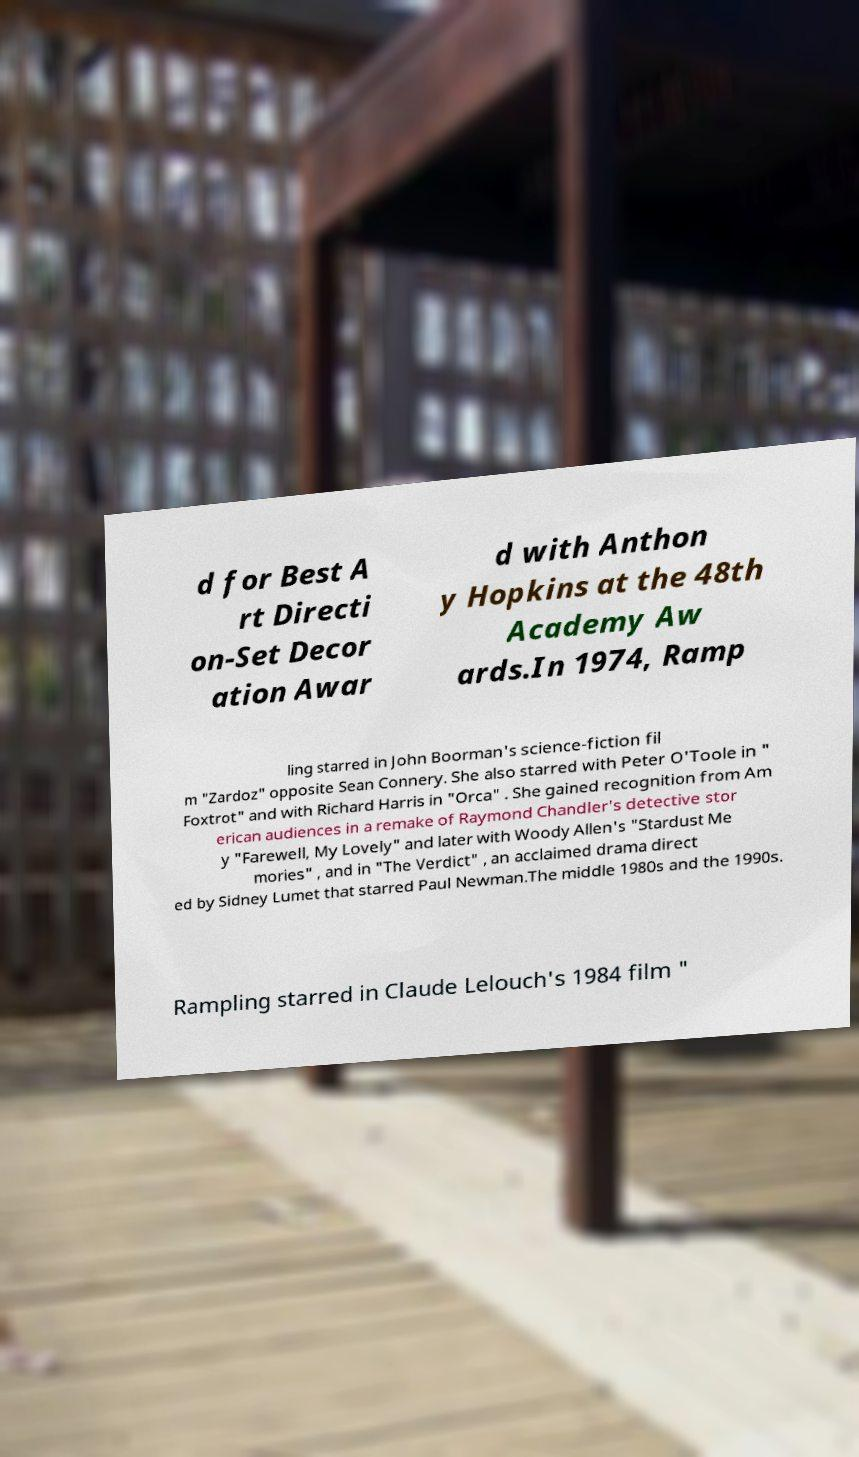What messages or text are displayed in this image? I need them in a readable, typed format. d for Best A rt Directi on-Set Decor ation Awar d with Anthon y Hopkins at the 48th Academy Aw ards.In 1974, Ramp ling starred in John Boorman's science-fiction fil m "Zardoz" opposite Sean Connery. She also starred with Peter O'Toole in " Foxtrot" and with Richard Harris in "Orca" . She gained recognition from Am erican audiences in a remake of Raymond Chandler's detective stor y "Farewell, My Lovely" and later with Woody Allen's "Stardust Me mories" , and in "The Verdict" , an acclaimed drama direct ed by Sidney Lumet that starred Paul Newman.The middle 1980s and the 1990s. Rampling starred in Claude Lelouch's 1984 film " 